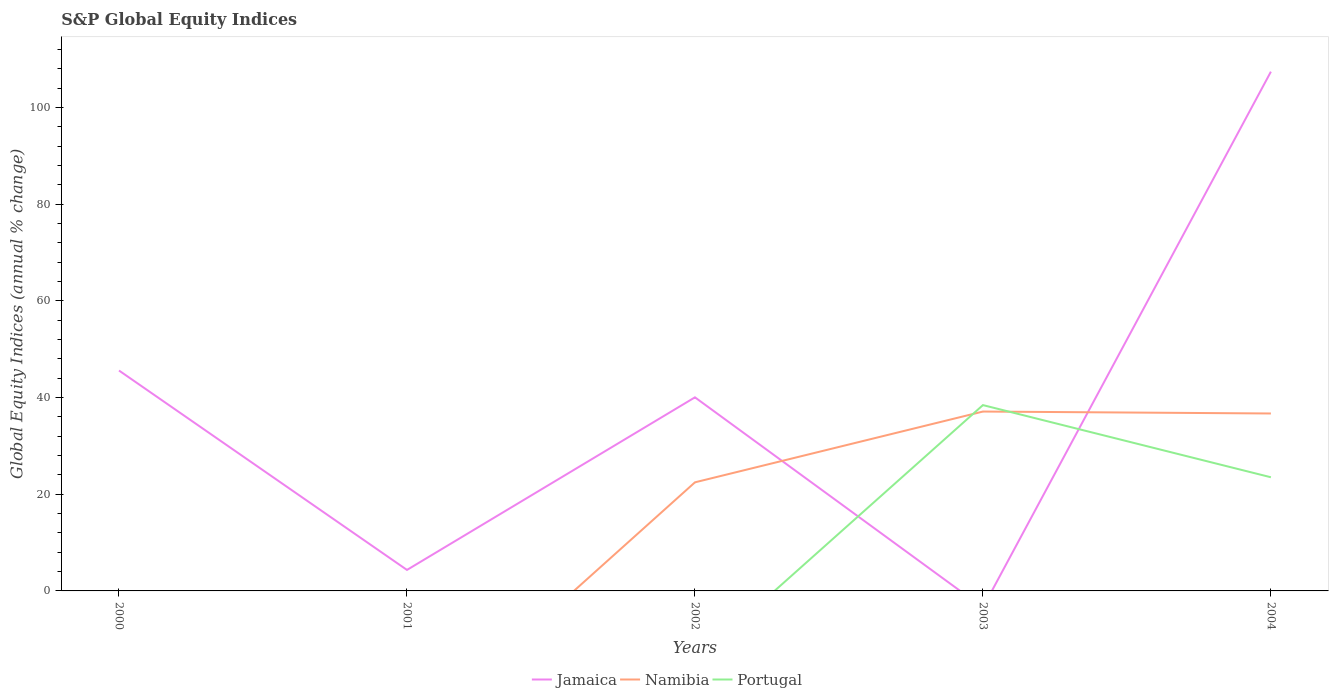How many different coloured lines are there?
Keep it short and to the point. 3. Does the line corresponding to Jamaica intersect with the line corresponding to Portugal?
Offer a terse response. Yes. Is the number of lines equal to the number of legend labels?
Provide a succinct answer. No. Across all years, what is the maximum global equity indices in Portugal?
Provide a short and direct response. 0. What is the total global equity indices in Jamaica in the graph?
Give a very brief answer. -61.81. What is the difference between the highest and the second highest global equity indices in Namibia?
Your response must be concise. 37.1. What is the difference between the highest and the lowest global equity indices in Portugal?
Ensure brevity in your answer.  2. Is the global equity indices in Namibia strictly greater than the global equity indices in Jamaica over the years?
Your answer should be compact. No. How many lines are there?
Keep it short and to the point. 3. How many years are there in the graph?
Offer a terse response. 5. Are the values on the major ticks of Y-axis written in scientific E-notation?
Ensure brevity in your answer.  No. Does the graph contain grids?
Keep it short and to the point. No. How many legend labels are there?
Offer a terse response. 3. How are the legend labels stacked?
Make the answer very short. Horizontal. What is the title of the graph?
Your answer should be very brief. S&P Global Equity Indices. Does "Latvia" appear as one of the legend labels in the graph?
Provide a succinct answer. No. What is the label or title of the Y-axis?
Ensure brevity in your answer.  Global Equity Indices (annual % change). What is the Global Equity Indices (annual % change) of Jamaica in 2000?
Offer a very short reply. 45.59. What is the Global Equity Indices (annual % change) in Namibia in 2000?
Offer a very short reply. 0. What is the Global Equity Indices (annual % change) of Portugal in 2000?
Ensure brevity in your answer.  0. What is the Global Equity Indices (annual % change) of Jamaica in 2001?
Your answer should be compact. 4.34. What is the Global Equity Indices (annual % change) in Namibia in 2001?
Your answer should be compact. 0. What is the Global Equity Indices (annual % change) of Jamaica in 2002?
Provide a short and direct response. 40.04. What is the Global Equity Indices (annual % change) of Namibia in 2002?
Ensure brevity in your answer.  22.46. What is the Global Equity Indices (annual % change) of Portugal in 2002?
Make the answer very short. 0. What is the Global Equity Indices (annual % change) of Namibia in 2003?
Offer a very short reply. 37.1. What is the Global Equity Indices (annual % change) in Portugal in 2003?
Your answer should be very brief. 38.43. What is the Global Equity Indices (annual % change) in Jamaica in 2004?
Keep it short and to the point. 107.4. What is the Global Equity Indices (annual % change) in Namibia in 2004?
Provide a succinct answer. 36.7. What is the Global Equity Indices (annual % change) in Portugal in 2004?
Provide a succinct answer. 23.51. Across all years, what is the maximum Global Equity Indices (annual % change) of Jamaica?
Offer a terse response. 107.4. Across all years, what is the maximum Global Equity Indices (annual % change) in Namibia?
Offer a terse response. 37.1. Across all years, what is the maximum Global Equity Indices (annual % change) of Portugal?
Provide a short and direct response. 38.43. Across all years, what is the minimum Global Equity Indices (annual % change) of Jamaica?
Keep it short and to the point. 0. Across all years, what is the minimum Global Equity Indices (annual % change) of Portugal?
Your answer should be compact. 0. What is the total Global Equity Indices (annual % change) of Jamaica in the graph?
Ensure brevity in your answer.  197.37. What is the total Global Equity Indices (annual % change) in Namibia in the graph?
Give a very brief answer. 96.26. What is the total Global Equity Indices (annual % change) of Portugal in the graph?
Your response must be concise. 61.94. What is the difference between the Global Equity Indices (annual % change) of Jamaica in 2000 and that in 2001?
Offer a very short reply. 41.24. What is the difference between the Global Equity Indices (annual % change) of Jamaica in 2000 and that in 2002?
Provide a succinct answer. 5.55. What is the difference between the Global Equity Indices (annual % change) of Jamaica in 2000 and that in 2004?
Provide a short and direct response. -61.81. What is the difference between the Global Equity Indices (annual % change) in Jamaica in 2001 and that in 2002?
Offer a very short reply. -35.7. What is the difference between the Global Equity Indices (annual % change) of Jamaica in 2001 and that in 2004?
Ensure brevity in your answer.  -103.06. What is the difference between the Global Equity Indices (annual % change) of Namibia in 2002 and that in 2003?
Offer a terse response. -14.64. What is the difference between the Global Equity Indices (annual % change) of Jamaica in 2002 and that in 2004?
Make the answer very short. -67.36. What is the difference between the Global Equity Indices (annual % change) of Namibia in 2002 and that in 2004?
Provide a short and direct response. -14.24. What is the difference between the Global Equity Indices (annual % change) of Portugal in 2003 and that in 2004?
Ensure brevity in your answer.  14.93. What is the difference between the Global Equity Indices (annual % change) of Jamaica in 2000 and the Global Equity Indices (annual % change) of Namibia in 2002?
Your answer should be very brief. 23.13. What is the difference between the Global Equity Indices (annual % change) of Jamaica in 2000 and the Global Equity Indices (annual % change) of Namibia in 2003?
Your response must be concise. 8.49. What is the difference between the Global Equity Indices (annual % change) in Jamaica in 2000 and the Global Equity Indices (annual % change) in Portugal in 2003?
Provide a short and direct response. 7.15. What is the difference between the Global Equity Indices (annual % change) of Jamaica in 2000 and the Global Equity Indices (annual % change) of Namibia in 2004?
Offer a terse response. 8.89. What is the difference between the Global Equity Indices (annual % change) in Jamaica in 2000 and the Global Equity Indices (annual % change) in Portugal in 2004?
Your answer should be very brief. 22.08. What is the difference between the Global Equity Indices (annual % change) of Jamaica in 2001 and the Global Equity Indices (annual % change) of Namibia in 2002?
Your response must be concise. -18.12. What is the difference between the Global Equity Indices (annual % change) in Jamaica in 2001 and the Global Equity Indices (annual % change) in Namibia in 2003?
Your response must be concise. -32.76. What is the difference between the Global Equity Indices (annual % change) of Jamaica in 2001 and the Global Equity Indices (annual % change) of Portugal in 2003?
Offer a very short reply. -34.09. What is the difference between the Global Equity Indices (annual % change) in Jamaica in 2001 and the Global Equity Indices (annual % change) in Namibia in 2004?
Offer a very short reply. -32.36. What is the difference between the Global Equity Indices (annual % change) in Jamaica in 2001 and the Global Equity Indices (annual % change) in Portugal in 2004?
Keep it short and to the point. -19.17. What is the difference between the Global Equity Indices (annual % change) of Jamaica in 2002 and the Global Equity Indices (annual % change) of Namibia in 2003?
Give a very brief answer. 2.94. What is the difference between the Global Equity Indices (annual % change) of Jamaica in 2002 and the Global Equity Indices (annual % change) of Portugal in 2003?
Give a very brief answer. 1.61. What is the difference between the Global Equity Indices (annual % change) of Namibia in 2002 and the Global Equity Indices (annual % change) of Portugal in 2003?
Your answer should be compact. -15.97. What is the difference between the Global Equity Indices (annual % change) of Jamaica in 2002 and the Global Equity Indices (annual % change) of Namibia in 2004?
Give a very brief answer. 3.34. What is the difference between the Global Equity Indices (annual % change) in Jamaica in 2002 and the Global Equity Indices (annual % change) in Portugal in 2004?
Your answer should be compact. 16.53. What is the difference between the Global Equity Indices (annual % change) of Namibia in 2002 and the Global Equity Indices (annual % change) of Portugal in 2004?
Make the answer very short. -1.05. What is the difference between the Global Equity Indices (annual % change) of Namibia in 2003 and the Global Equity Indices (annual % change) of Portugal in 2004?
Provide a short and direct response. 13.59. What is the average Global Equity Indices (annual % change) in Jamaica per year?
Provide a succinct answer. 39.47. What is the average Global Equity Indices (annual % change) of Namibia per year?
Provide a short and direct response. 19.25. What is the average Global Equity Indices (annual % change) of Portugal per year?
Make the answer very short. 12.39. In the year 2002, what is the difference between the Global Equity Indices (annual % change) of Jamaica and Global Equity Indices (annual % change) of Namibia?
Offer a terse response. 17.58. In the year 2003, what is the difference between the Global Equity Indices (annual % change) in Namibia and Global Equity Indices (annual % change) in Portugal?
Your answer should be very brief. -1.33. In the year 2004, what is the difference between the Global Equity Indices (annual % change) in Jamaica and Global Equity Indices (annual % change) in Namibia?
Your answer should be very brief. 70.7. In the year 2004, what is the difference between the Global Equity Indices (annual % change) of Jamaica and Global Equity Indices (annual % change) of Portugal?
Give a very brief answer. 83.89. In the year 2004, what is the difference between the Global Equity Indices (annual % change) in Namibia and Global Equity Indices (annual % change) in Portugal?
Make the answer very short. 13.19. What is the ratio of the Global Equity Indices (annual % change) of Jamaica in 2000 to that in 2001?
Ensure brevity in your answer.  10.5. What is the ratio of the Global Equity Indices (annual % change) of Jamaica in 2000 to that in 2002?
Offer a terse response. 1.14. What is the ratio of the Global Equity Indices (annual % change) of Jamaica in 2000 to that in 2004?
Provide a short and direct response. 0.42. What is the ratio of the Global Equity Indices (annual % change) of Jamaica in 2001 to that in 2002?
Give a very brief answer. 0.11. What is the ratio of the Global Equity Indices (annual % change) of Jamaica in 2001 to that in 2004?
Provide a short and direct response. 0.04. What is the ratio of the Global Equity Indices (annual % change) in Namibia in 2002 to that in 2003?
Provide a short and direct response. 0.61. What is the ratio of the Global Equity Indices (annual % change) of Jamaica in 2002 to that in 2004?
Offer a terse response. 0.37. What is the ratio of the Global Equity Indices (annual % change) in Namibia in 2002 to that in 2004?
Offer a very short reply. 0.61. What is the ratio of the Global Equity Indices (annual % change) of Namibia in 2003 to that in 2004?
Provide a succinct answer. 1.01. What is the ratio of the Global Equity Indices (annual % change) of Portugal in 2003 to that in 2004?
Provide a succinct answer. 1.64. What is the difference between the highest and the second highest Global Equity Indices (annual % change) of Jamaica?
Offer a very short reply. 61.81. What is the difference between the highest and the lowest Global Equity Indices (annual % change) in Jamaica?
Provide a short and direct response. 107.4. What is the difference between the highest and the lowest Global Equity Indices (annual % change) of Namibia?
Provide a succinct answer. 37.1. What is the difference between the highest and the lowest Global Equity Indices (annual % change) of Portugal?
Give a very brief answer. 38.43. 